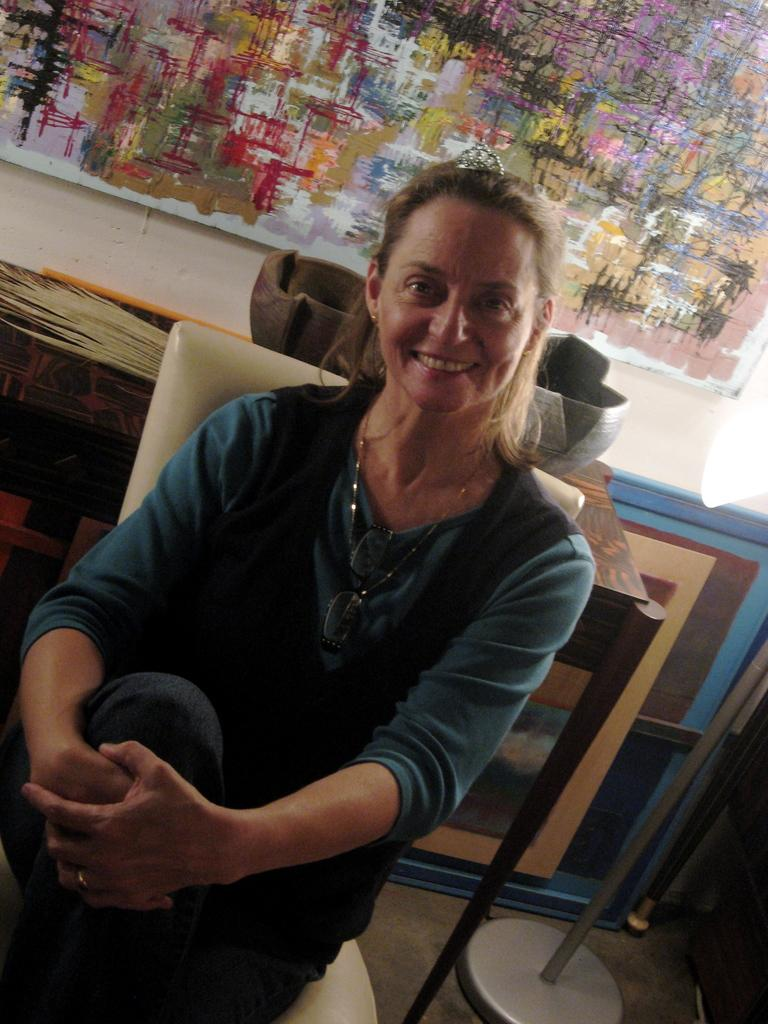What is the main subject of the image? The main subject of the image is a woman. What is the woman doing in the image? The woman is sitting on a chair and smiling. What is located behind the woman? There is a table behind the woman. What can be seen on the wall in the background? There is a painting on the wall in the background. How many dimes are on the table in the image? There is no mention of dimes in the image, so it is impossible to determine their presence or quantity. 